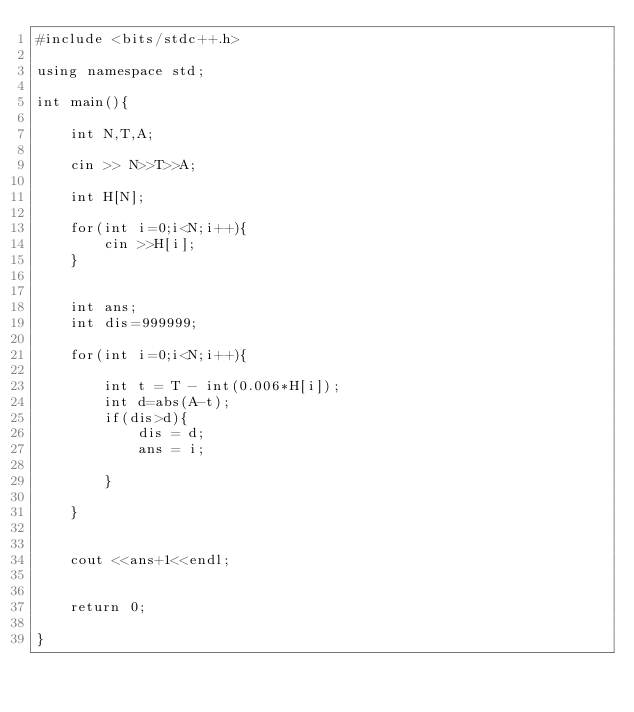Convert code to text. <code><loc_0><loc_0><loc_500><loc_500><_C++_>#include <bits/stdc++.h>

using namespace std;

int main(){

	int N,T,A;

	cin >> N>>T>>A;

	int H[N];

	for(int i=0;i<N;i++){
		cin >>H[i];
	}	


	int ans;
	int dis=999999;
	
	for(int i=0;i<N;i++){
	
		int t = T - int(0.006*H[i]);
		int d=abs(A-t);
		if(dis>d){
			dis = d;
			ans = i;
		
		}
	
	}


	cout <<ans+1<<endl;


	return 0;

}</code> 